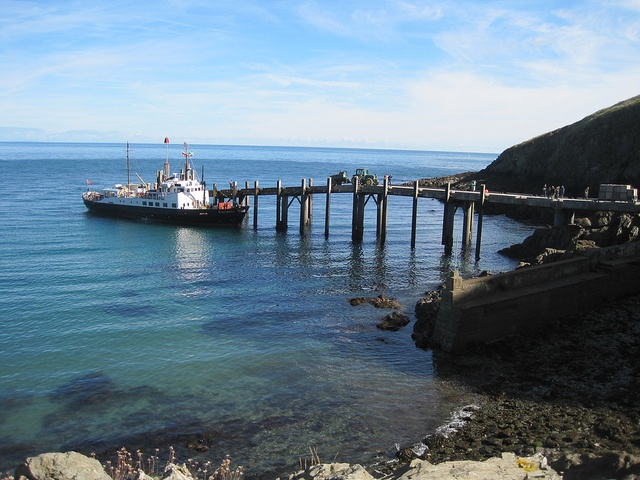Describe the objects in this image and their specific colors. I can see boat in lightblue, black, white, and gray tones, truck in lightblue, black, gray, and darkgray tones, people in lightblue, black, gray, and darkgray tones, people in lightblue, black, and gray tones, and people in lightblue, navy, and gray tones in this image. 